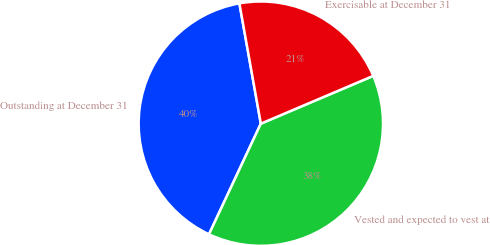Convert chart to OTSL. <chart><loc_0><loc_0><loc_500><loc_500><pie_chart><fcel>Outstanding at December 31<fcel>Vested and expected to vest at<fcel>Exercisable at December 31<nl><fcel>40.22%<fcel>38.37%<fcel>21.41%<nl></chart> 